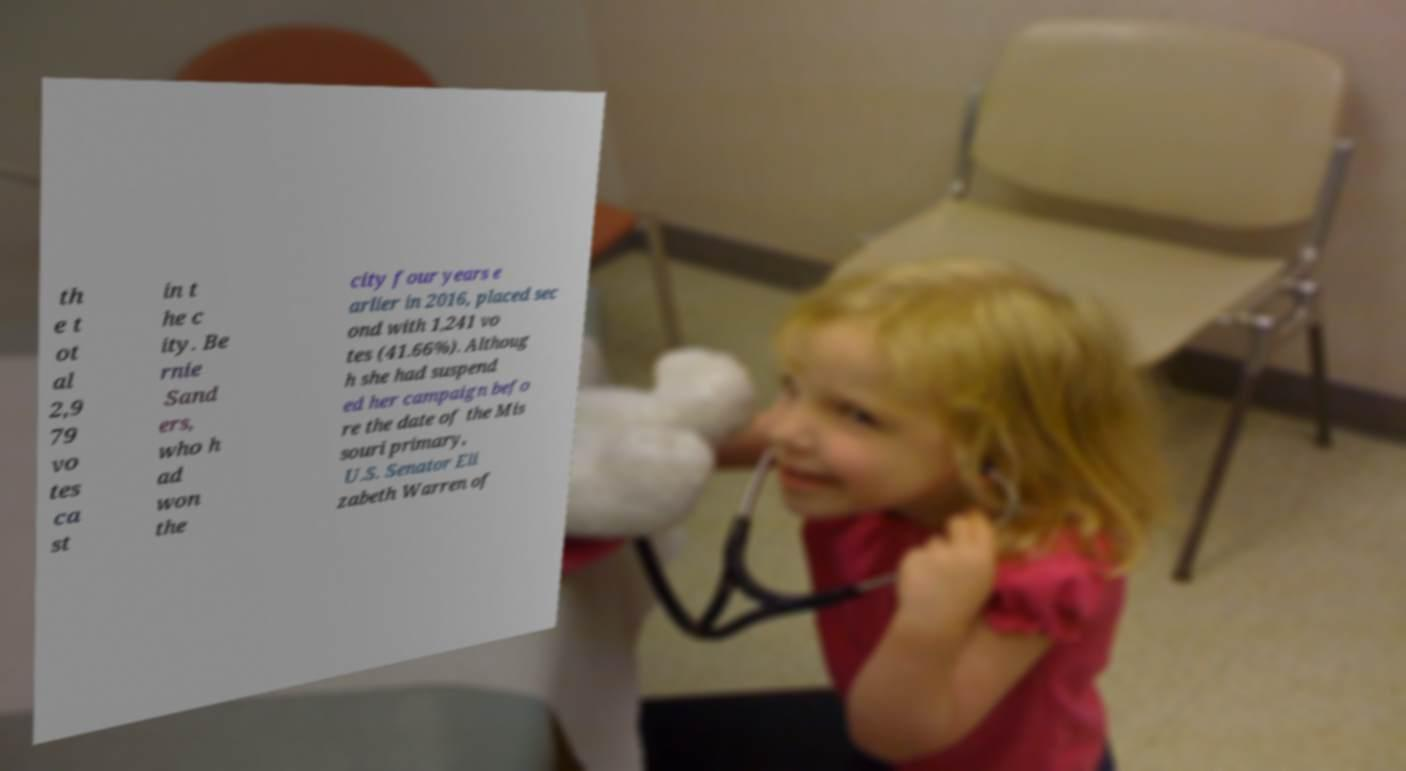Can you read and provide the text displayed in the image?This photo seems to have some interesting text. Can you extract and type it out for me? th e t ot al 2,9 79 vo tes ca st in t he c ity. Be rnie Sand ers, who h ad won the city four years e arlier in 2016, placed sec ond with 1,241 vo tes (41.66%). Althoug h she had suspend ed her campaign befo re the date of the Mis souri primary, U.S. Senator Eli zabeth Warren of 